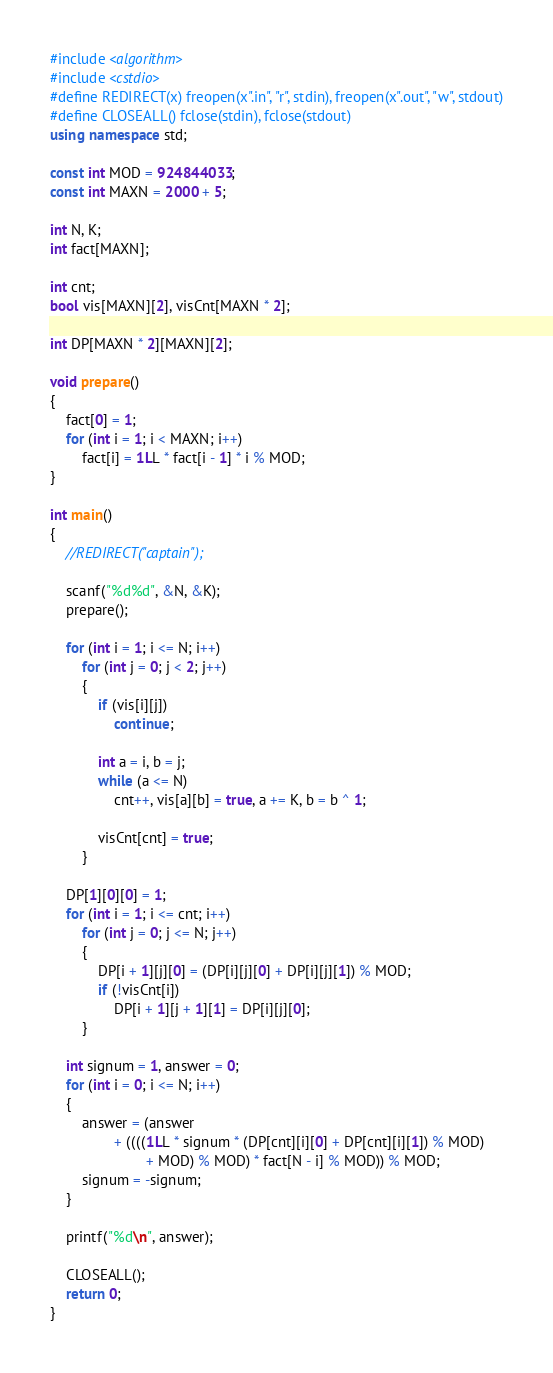Convert code to text. <code><loc_0><loc_0><loc_500><loc_500><_C++_>#include <algorithm>
#include <cstdio>
#define REDIRECT(x) freopen(x".in", "r", stdin), freopen(x".out", "w", stdout)
#define CLOSEALL() fclose(stdin), fclose(stdout)
using namespace std;

const int MOD = 924844033;
const int MAXN = 2000 + 5;

int N, K;
int fact[MAXN];

int cnt;
bool vis[MAXN][2], visCnt[MAXN * 2];

int DP[MAXN * 2][MAXN][2];

void prepare()
{
	fact[0] = 1;
	for (int i = 1; i < MAXN; i++)
		fact[i] = 1LL * fact[i - 1] * i % MOD;
}

int main()
{
	//REDIRECT("captain");

	scanf("%d%d", &N, &K);
	prepare();

	for (int i = 1; i <= N; i++)
		for (int j = 0; j < 2; j++)
		{
			if (vis[i][j])
				continue;

			int a = i, b = j;
			while (a <= N)
				cnt++, vis[a][b] = true, a += K, b = b ^ 1;

			visCnt[cnt] = true;
		}

	DP[1][0][0] = 1;
	for (int i = 1; i <= cnt; i++)
		for (int j = 0; j <= N; j++)
		{
			DP[i + 1][j][0] = (DP[i][j][0] + DP[i][j][1]) % MOD;
			if (!visCnt[i])
				DP[i + 1][j + 1][1] = DP[i][j][0];
		}

	int signum = 1, answer = 0;
	for (int i = 0; i <= N; i++)
	{
		answer = (answer
				+ ((((1LL * signum * (DP[cnt][i][0] + DP[cnt][i][1]) % MOD)
						+ MOD) % MOD) * fact[N - i] % MOD)) % MOD;
		signum = -signum;
	}

	printf("%d\n", answer);

	CLOSEALL();
	return 0;
}
</code> 